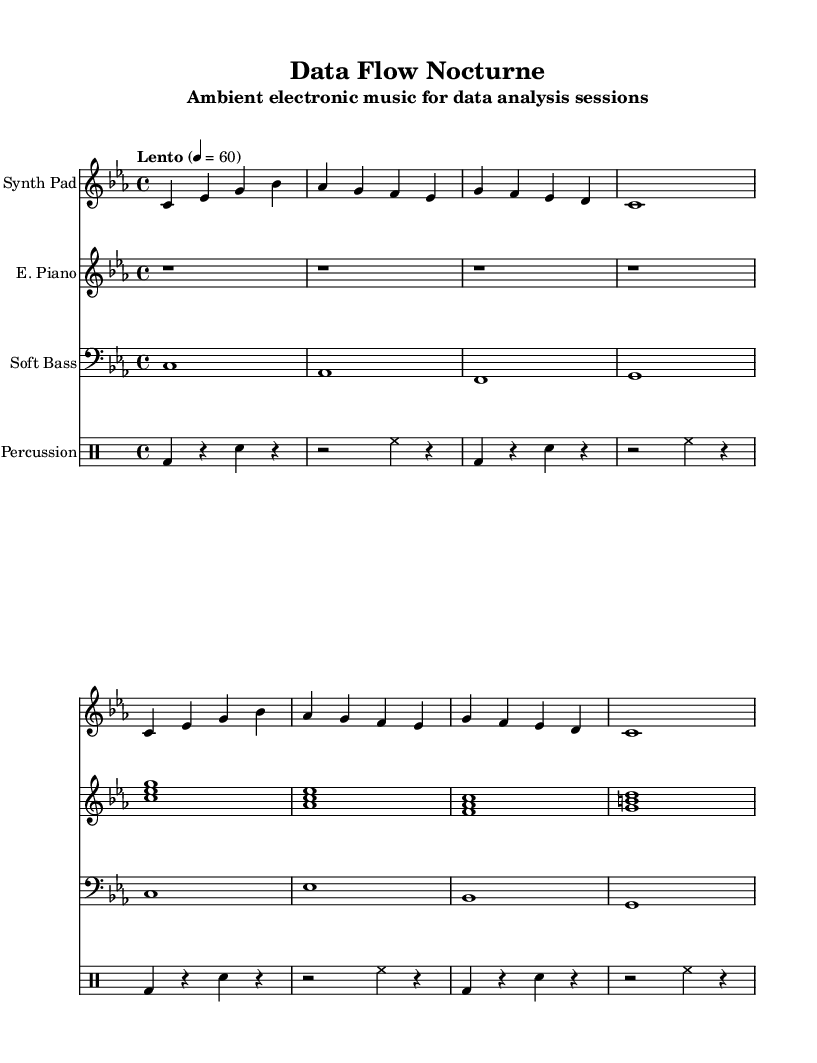what is the key signature of this music? The key signature is C minor, which has three flats (B, E, and A). This can be observed at the beginning of the sheet music before the staff lines.
Answer: C minor what is the time signature of this music? The time signature is 4/4, which indicates that there are four beats in each measure and a quarter note receives one beat. This is typically found at the beginning of the score next to the clef.
Answer: 4/4 what is the tempo marking for this music? The tempo marking is "Lento," indicating a slow pace. The exact speed is set to 60 beats per minute, as specified in the tempo indication at the start of the score.
Answer: Lento how many measures are in the synth pad part? The synth pad part consists of 8 measures. By counting the individual measures from the beginning of the staff line to the end, we can see a total of eight groups of time signatures, usually separated by vertical lines.
Answer: 8 what type of instruments are used in this composition? The composition features a Synth Pad, Electric Piano, Soft Bass, and Ambient Percussion. This can be gathered from the labeled instrument names above each staff in the score.
Answer: Synth Pad, Electric Piano, Soft Bass, Ambient Percussion which instrument has the longest note duration in the first section? The Soft Bass has the longest note duration, which is a whole note (1). In the first section of the score, this can be identified in the measures under the Soft Bass staff where all notes are held for the entire measure without breaks.
Answer: Soft Bass how many staves are present in this score? The score contains four staves. Each staff corresponds to an individual instrument, as indicated by the instrument names positioned above them.
Answer: 4 